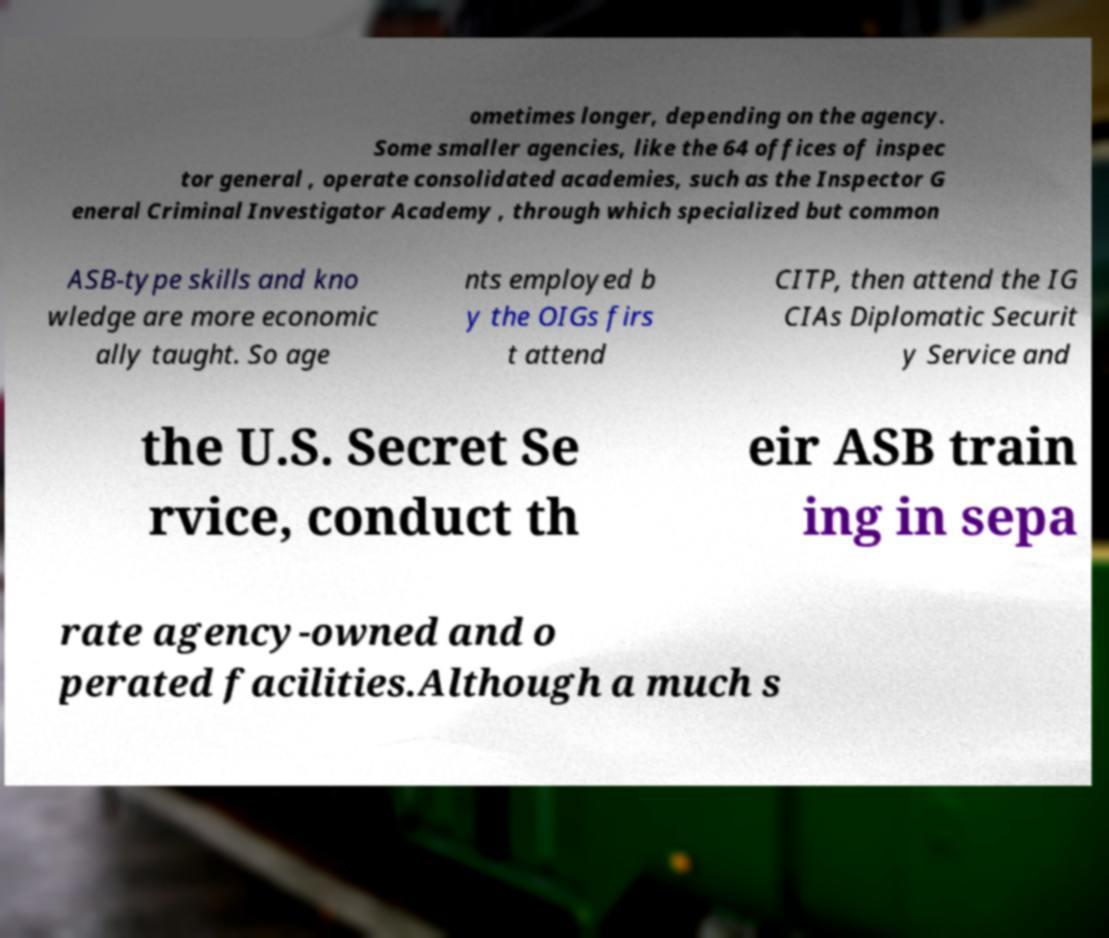Please read and relay the text visible in this image. What does it say? ometimes longer, depending on the agency. Some smaller agencies, like the 64 offices of inspec tor general , operate consolidated academies, such as the Inspector G eneral Criminal Investigator Academy , through which specialized but common ASB-type skills and kno wledge are more economic ally taught. So age nts employed b y the OIGs firs t attend CITP, then attend the IG CIAs Diplomatic Securit y Service and the U.S. Secret Se rvice, conduct th eir ASB train ing in sepa rate agency-owned and o perated facilities.Although a much s 